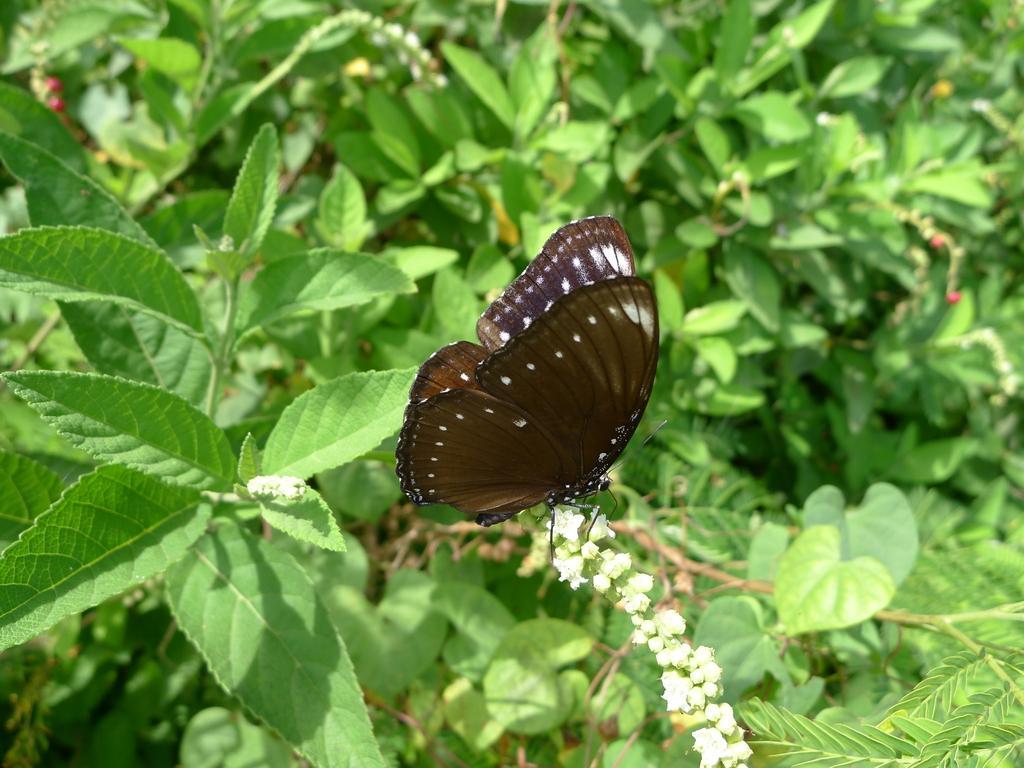Please provide a concise description of this image. In this image we can see stems with leaves and flowers. On the flowers there is a butterfly. 